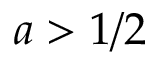Convert formula to latex. <formula><loc_0><loc_0><loc_500><loc_500>a > 1 / 2</formula> 